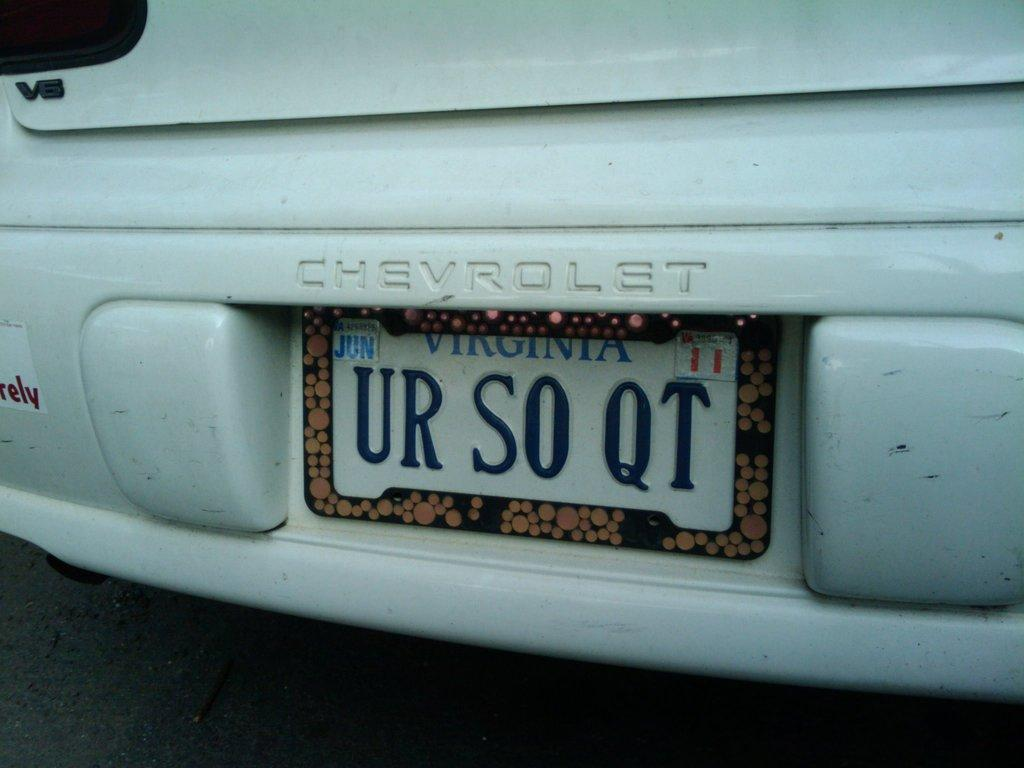Provide a one-sentence caption for the provided image. The car is from Virginia with license plate number UR S0 QT. 